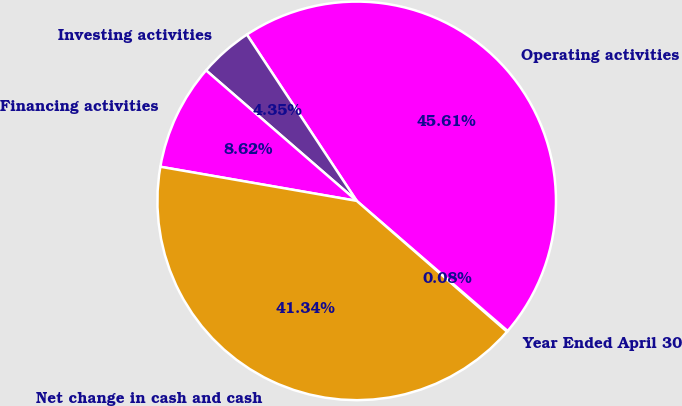Convert chart to OTSL. <chart><loc_0><loc_0><loc_500><loc_500><pie_chart><fcel>Year Ended April 30<fcel>Operating activities<fcel>Investing activities<fcel>Financing activities<fcel>Net change in cash and cash<nl><fcel>0.08%<fcel>45.6%<fcel>4.35%<fcel>8.62%<fcel>41.33%<nl></chart> 